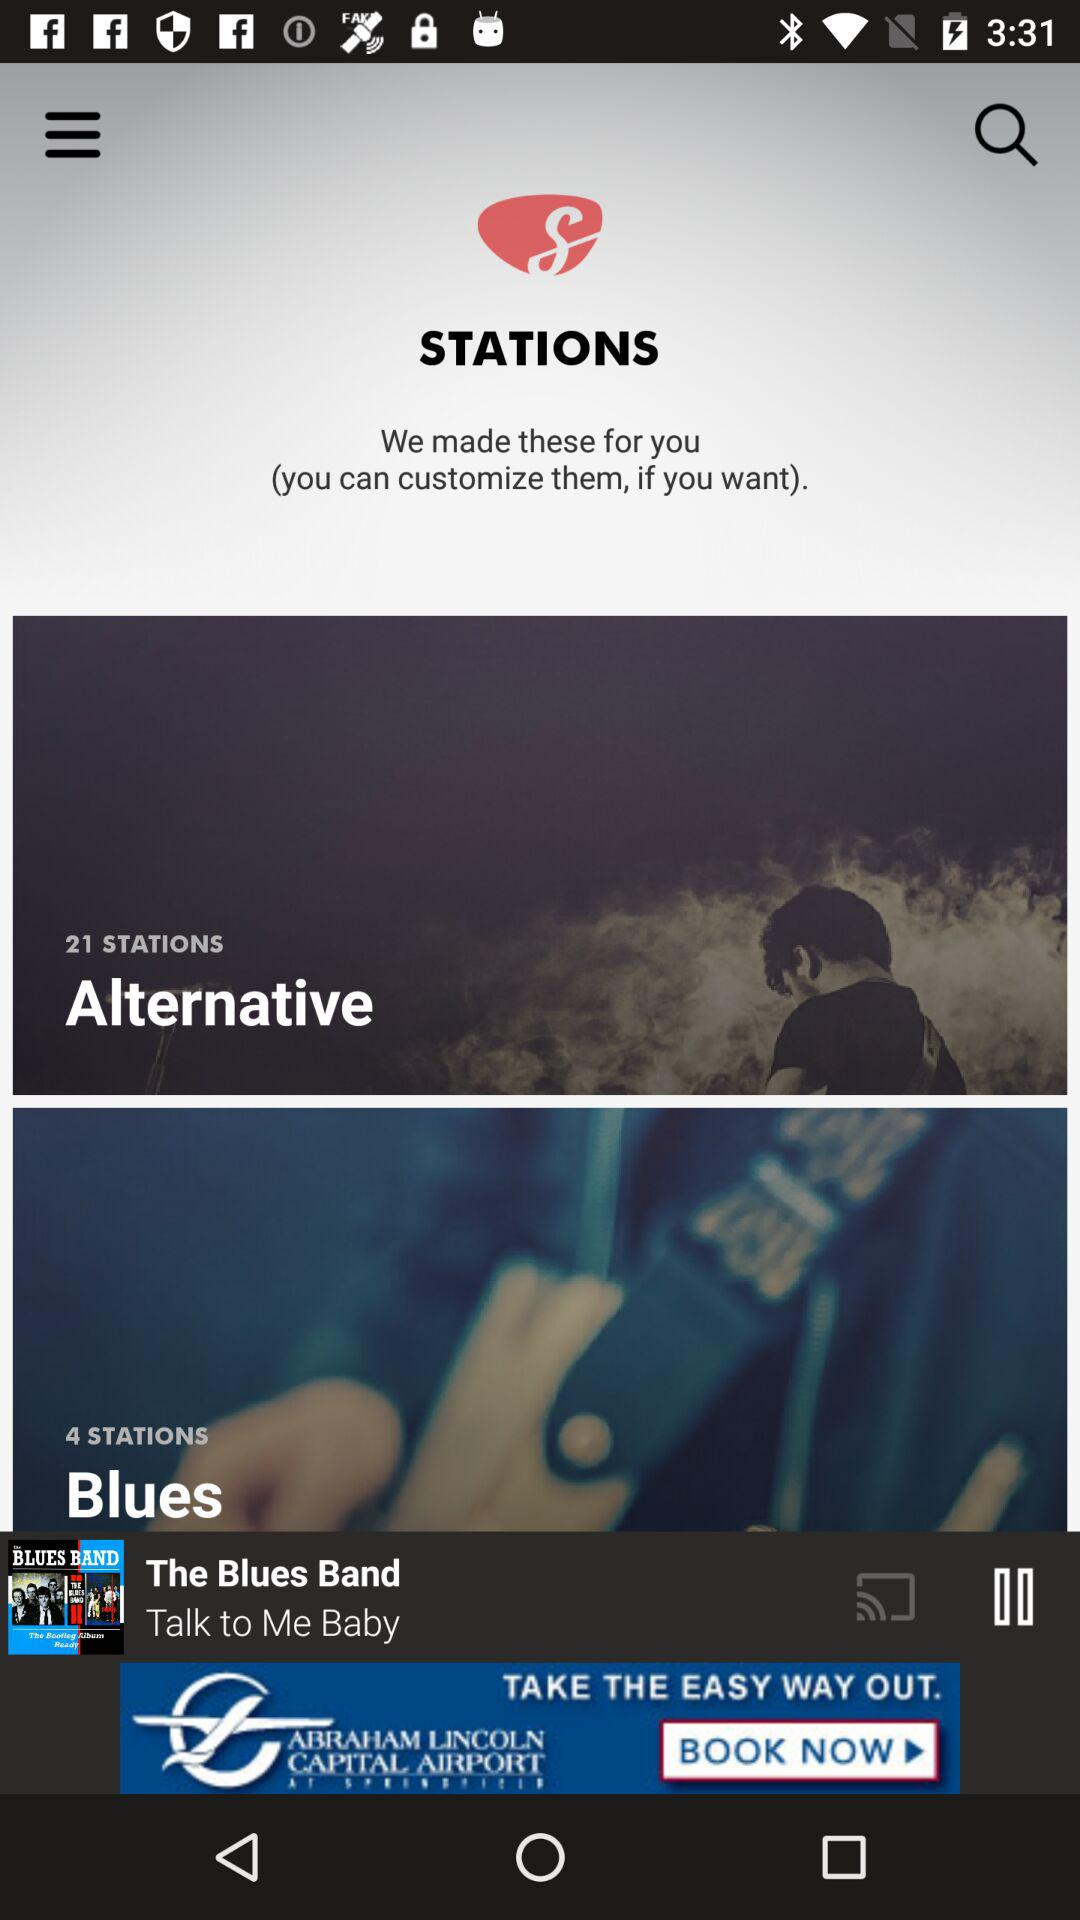How many stations are in the Alternative category?
Answer the question using a single word or phrase. 21 